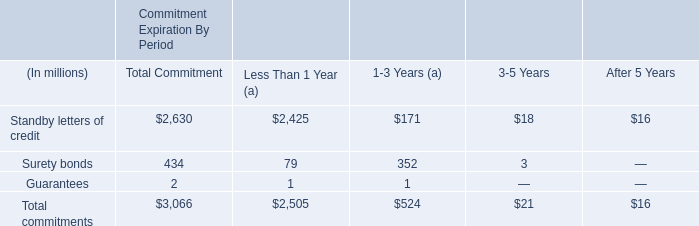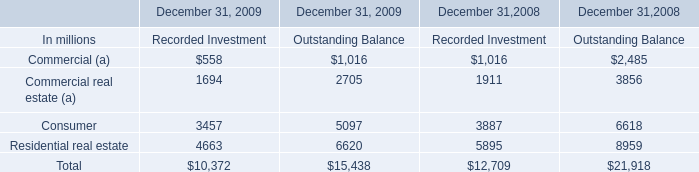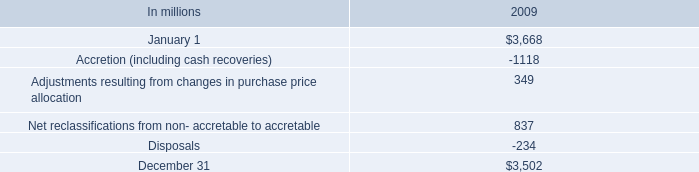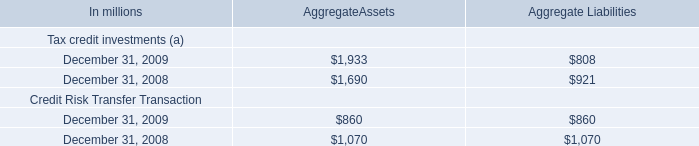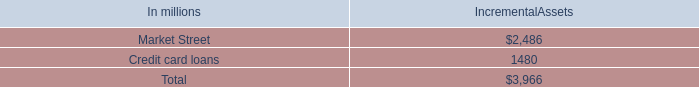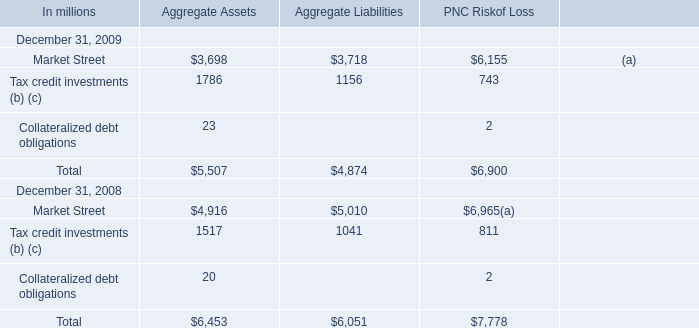DoesTax credit investments (b) (c) forAggregate Assets keeps increasing each year between 2008 and 2009? 
Answer: yes. 